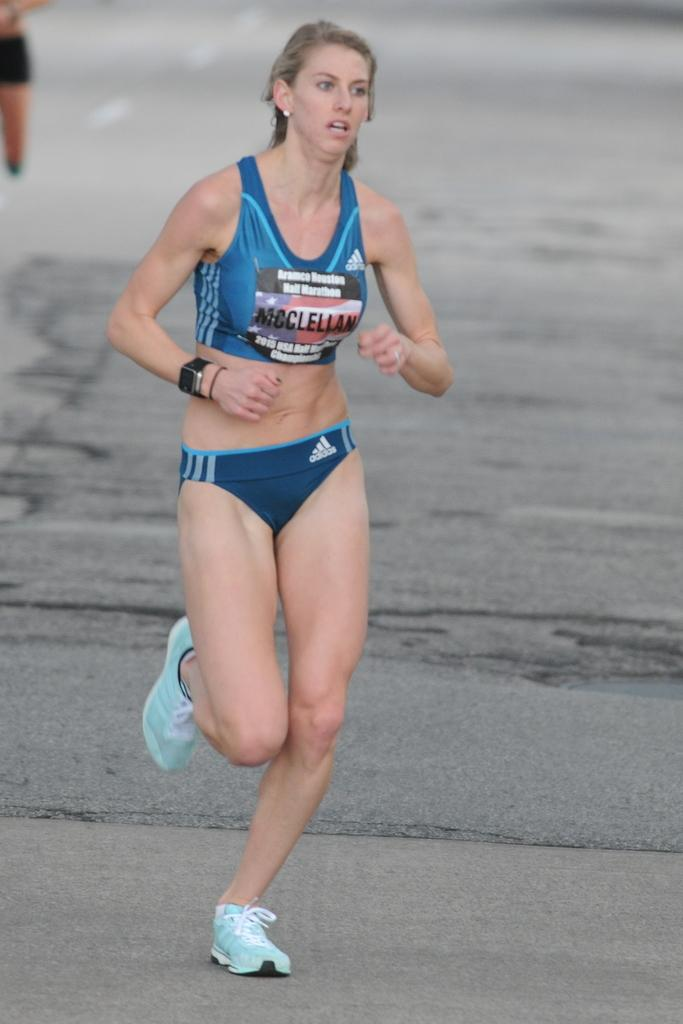<image>
Offer a succinct explanation of the picture presented. Runner McClellan is competing in the Houston Half Marathon. 